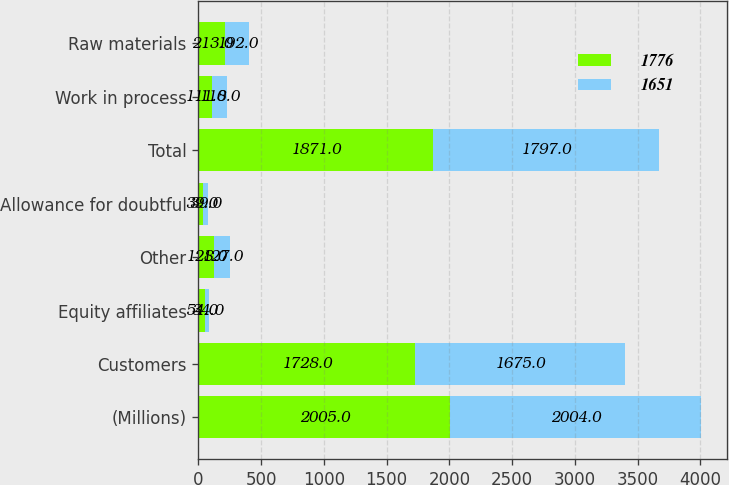Convert chart. <chart><loc_0><loc_0><loc_500><loc_500><stacked_bar_chart><ecel><fcel>(Millions)<fcel>Customers<fcel>Equity affiliates<fcel>Other<fcel>Allowance for doubtful<fcel>Total<fcel>Work in process<fcel>Raw materials<nl><fcel>1776<fcel>2005<fcel>1728<fcel>54<fcel>128<fcel>39<fcel>1871<fcel>111<fcel>213<nl><fcel>1651<fcel>2004<fcel>1675<fcel>34<fcel>127<fcel>39<fcel>1797<fcel>118<fcel>192<nl></chart> 